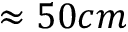<formula> <loc_0><loc_0><loc_500><loc_500>\approx 5 0 c m</formula> 